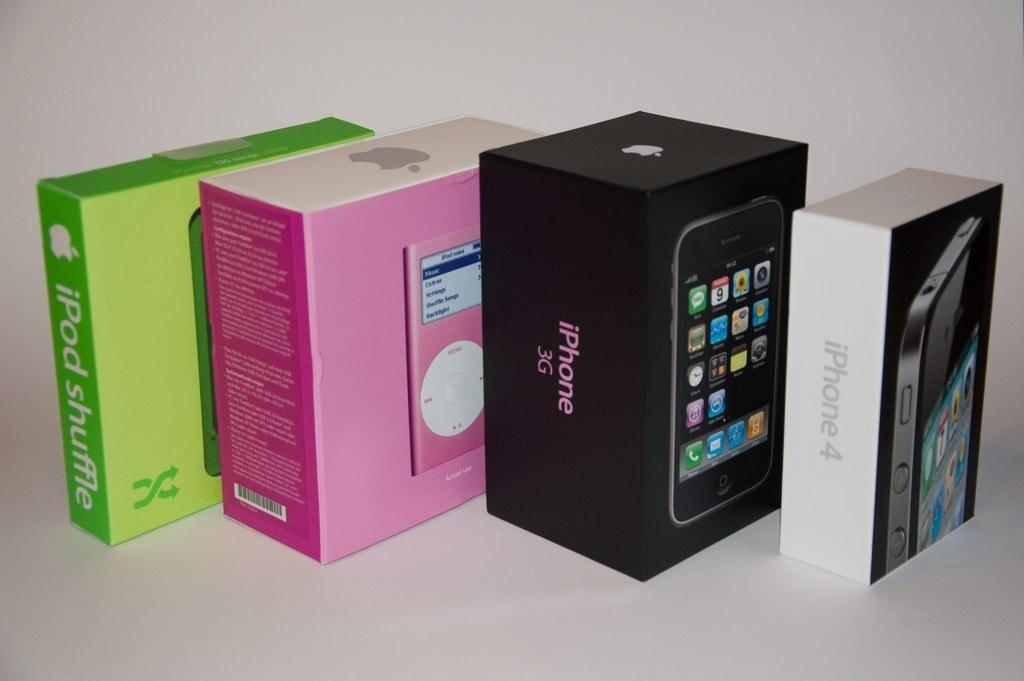<image>
Describe the image concisely. A black iPhone 3G box sits next to a pink iPod box. 